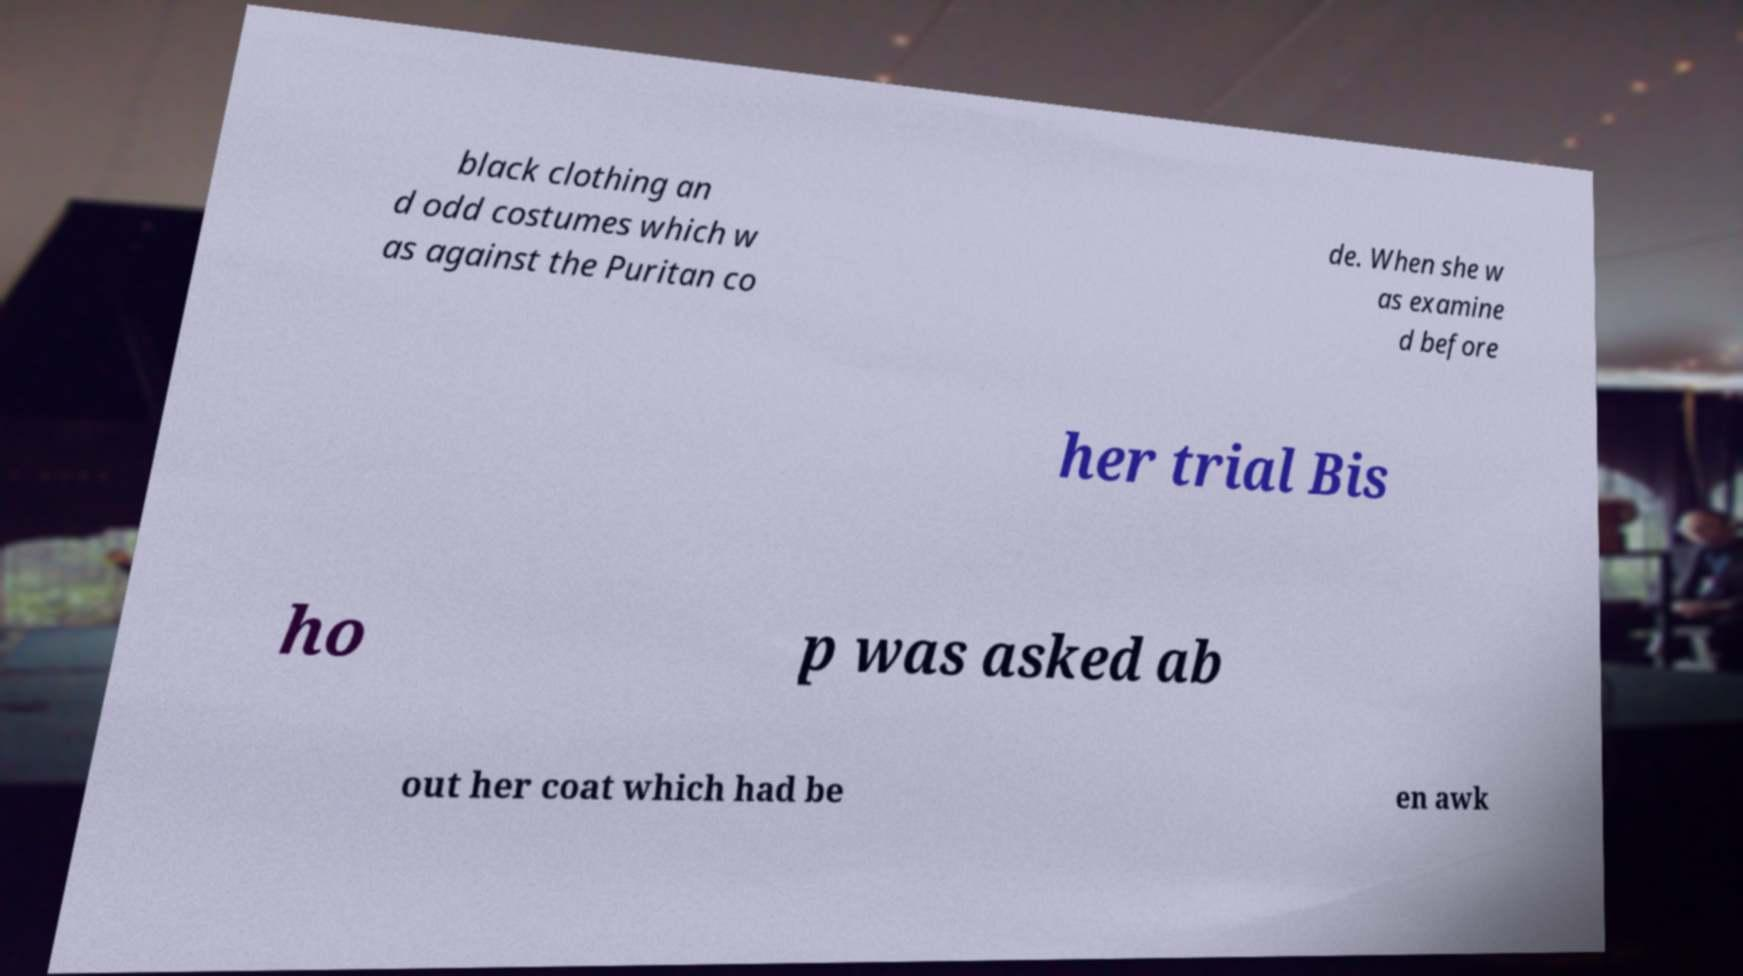There's text embedded in this image that I need extracted. Can you transcribe it verbatim? black clothing an d odd costumes which w as against the Puritan co de. When she w as examine d before her trial Bis ho p was asked ab out her coat which had be en awk 